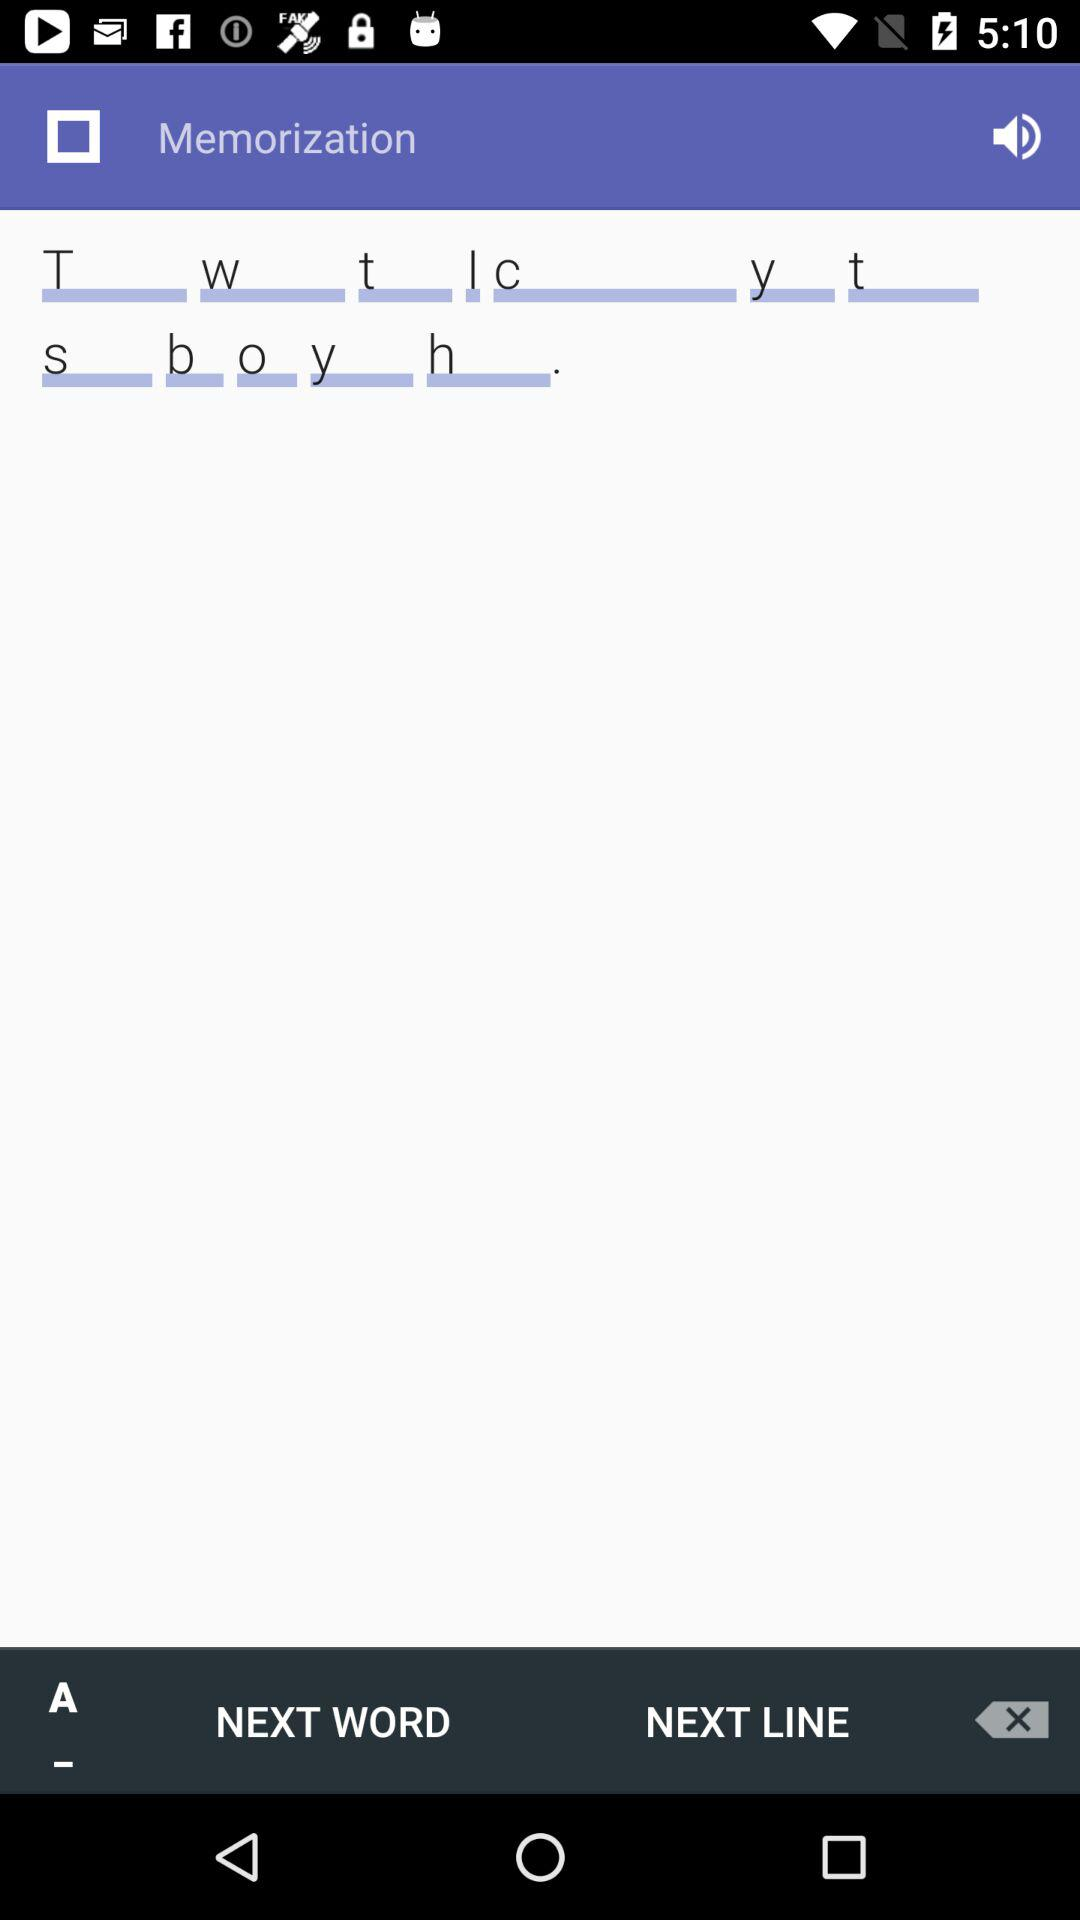What is the application name? The application name is "Memorization". 